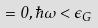<formula> <loc_0><loc_0><loc_500><loc_500>= 0 , \hbar { \omega } < \epsilon _ { G }</formula> 